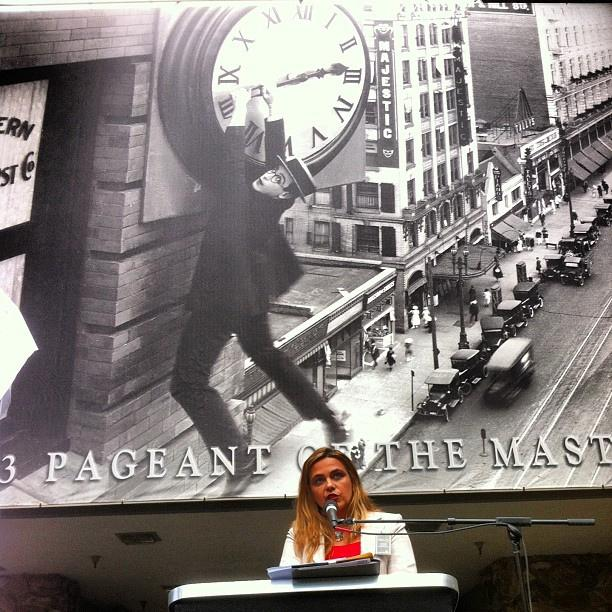What is this movie most likely to be? Please explain your reasoning. comedy. The person hanging from the clock is being comedic. 